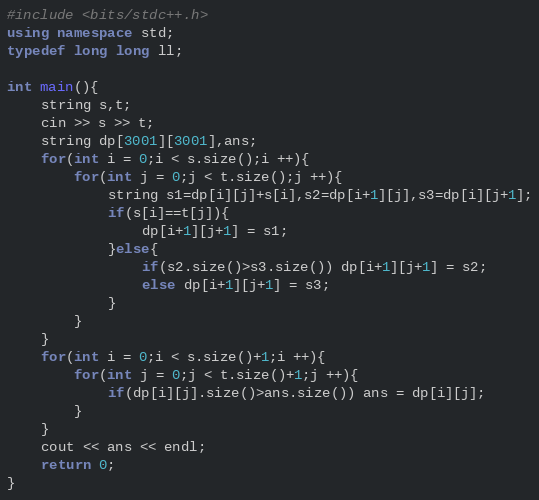Convert code to text. <code><loc_0><loc_0><loc_500><loc_500><_C++_>#include <bits/stdc++.h>
using namespace std;
typedef long long ll;

int main(){
    string s,t;
    cin >> s >> t;
    string dp[3001][3001],ans;
    for(int i = 0;i < s.size();i ++){
        for(int j = 0;j < t.size();j ++){
            string s1=dp[i][j]+s[i],s2=dp[i+1][j],s3=dp[i][j+1];
            if(s[i]==t[j]){
                dp[i+1][j+1] = s1;
            }else{
                if(s2.size()>s3.size()) dp[i+1][j+1] = s2;
                else dp[i+1][j+1] = s3;
            }
        }
    }
    for(int i = 0;i < s.size()+1;i ++){
        for(int j = 0;j < t.size()+1;j ++){
            if(dp[i][j].size()>ans.size()) ans = dp[i][j];
        }
    }
    cout << ans << endl;
    return 0;
}</code> 